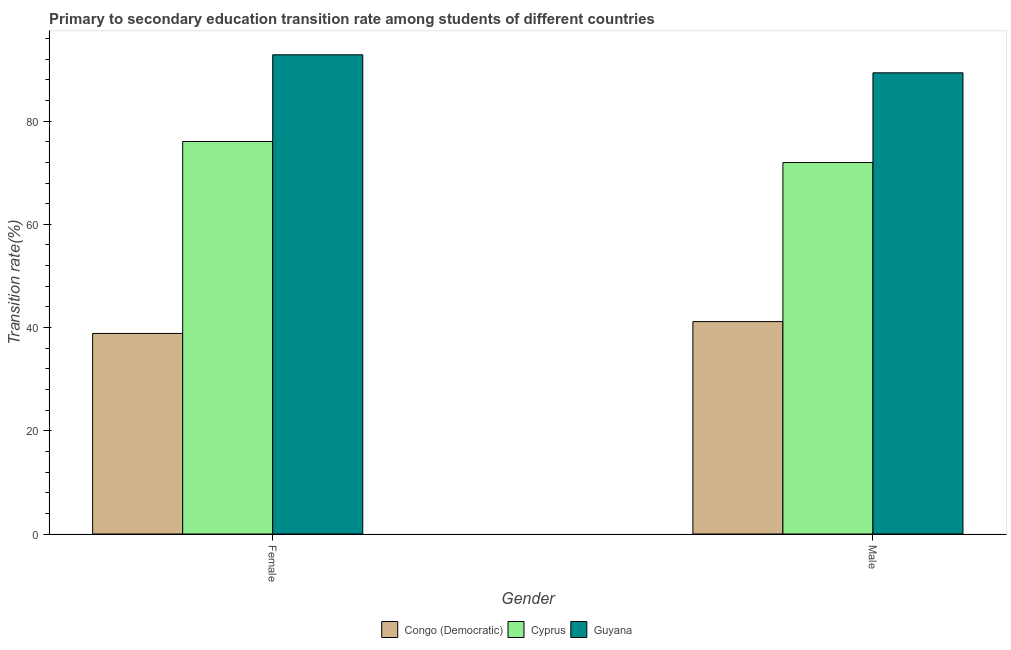How many groups of bars are there?
Your answer should be very brief. 2. Are the number of bars on each tick of the X-axis equal?
Your answer should be compact. Yes. How many bars are there on the 2nd tick from the right?
Offer a terse response. 3. What is the label of the 2nd group of bars from the left?
Your answer should be compact. Male. What is the transition rate among female students in Congo (Democratic)?
Give a very brief answer. 38.85. Across all countries, what is the maximum transition rate among female students?
Make the answer very short. 92.84. Across all countries, what is the minimum transition rate among female students?
Your answer should be compact. 38.85. In which country was the transition rate among female students maximum?
Offer a very short reply. Guyana. In which country was the transition rate among female students minimum?
Your answer should be compact. Congo (Democratic). What is the total transition rate among female students in the graph?
Your response must be concise. 207.74. What is the difference between the transition rate among female students in Guyana and that in Cyprus?
Your answer should be compact. 16.8. What is the difference between the transition rate among female students in Congo (Democratic) and the transition rate among male students in Guyana?
Make the answer very short. -50.49. What is the average transition rate among male students per country?
Keep it short and to the point. 67.49. What is the difference between the transition rate among female students and transition rate among male students in Congo (Democratic)?
Make the answer very short. -2.29. In how many countries, is the transition rate among male students greater than 52 %?
Your answer should be very brief. 2. What is the ratio of the transition rate among female students in Guyana to that in Cyprus?
Provide a succinct answer. 1.22. Is the transition rate among male students in Cyprus less than that in Guyana?
Your answer should be very brief. Yes. In how many countries, is the transition rate among male students greater than the average transition rate among male students taken over all countries?
Offer a terse response. 2. What does the 2nd bar from the left in Male represents?
Your answer should be compact. Cyprus. What does the 3rd bar from the right in Male represents?
Make the answer very short. Congo (Democratic). Are all the bars in the graph horizontal?
Offer a very short reply. No. How many countries are there in the graph?
Ensure brevity in your answer.  3. Are the values on the major ticks of Y-axis written in scientific E-notation?
Make the answer very short. No. Where does the legend appear in the graph?
Your answer should be very brief. Bottom center. What is the title of the graph?
Your answer should be very brief. Primary to secondary education transition rate among students of different countries. Does "Turkmenistan" appear as one of the legend labels in the graph?
Provide a short and direct response. No. What is the label or title of the Y-axis?
Make the answer very short. Transition rate(%). What is the Transition rate(%) in Congo (Democratic) in Female?
Your answer should be compact. 38.85. What is the Transition rate(%) in Cyprus in Female?
Provide a short and direct response. 76.04. What is the Transition rate(%) of Guyana in Female?
Make the answer very short. 92.84. What is the Transition rate(%) in Congo (Democratic) in Male?
Provide a succinct answer. 41.15. What is the Transition rate(%) of Cyprus in Male?
Your response must be concise. 71.96. What is the Transition rate(%) of Guyana in Male?
Your answer should be very brief. 89.35. Across all Gender, what is the maximum Transition rate(%) in Congo (Democratic)?
Your answer should be compact. 41.15. Across all Gender, what is the maximum Transition rate(%) of Cyprus?
Keep it short and to the point. 76.04. Across all Gender, what is the maximum Transition rate(%) in Guyana?
Offer a terse response. 92.84. Across all Gender, what is the minimum Transition rate(%) of Congo (Democratic)?
Make the answer very short. 38.85. Across all Gender, what is the minimum Transition rate(%) in Cyprus?
Your answer should be compact. 71.96. Across all Gender, what is the minimum Transition rate(%) in Guyana?
Provide a short and direct response. 89.35. What is the total Transition rate(%) of Congo (Democratic) in the graph?
Provide a short and direct response. 80. What is the total Transition rate(%) in Cyprus in the graph?
Your response must be concise. 148.01. What is the total Transition rate(%) in Guyana in the graph?
Offer a terse response. 182.19. What is the difference between the Transition rate(%) of Congo (Democratic) in Female and that in Male?
Your answer should be very brief. -2.29. What is the difference between the Transition rate(%) of Cyprus in Female and that in Male?
Offer a terse response. 4.08. What is the difference between the Transition rate(%) in Guyana in Female and that in Male?
Give a very brief answer. 3.49. What is the difference between the Transition rate(%) of Congo (Democratic) in Female and the Transition rate(%) of Cyprus in Male?
Offer a terse response. -33.11. What is the difference between the Transition rate(%) of Congo (Democratic) in Female and the Transition rate(%) of Guyana in Male?
Give a very brief answer. -50.49. What is the difference between the Transition rate(%) of Cyprus in Female and the Transition rate(%) of Guyana in Male?
Give a very brief answer. -13.3. What is the average Transition rate(%) in Congo (Democratic) per Gender?
Provide a short and direct response. 40. What is the average Transition rate(%) of Cyprus per Gender?
Keep it short and to the point. 74. What is the average Transition rate(%) in Guyana per Gender?
Ensure brevity in your answer.  91.09. What is the difference between the Transition rate(%) of Congo (Democratic) and Transition rate(%) of Cyprus in Female?
Offer a very short reply. -37.19. What is the difference between the Transition rate(%) in Congo (Democratic) and Transition rate(%) in Guyana in Female?
Your answer should be very brief. -53.99. What is the difference between the Transition rate(%) of Cyprus and Transition rate(%) of Guyana in Female?
Give a very brief answer. -16.8. What is the difference between the Transition rate(%) of Congo (Democratic) and Transition rate(%) of Cyprus in Male?
Provide a short and direct response. -30.82. What is the difference between the Transition rate(%) in Congo (Democratic) and Transition rate(%) in Guyana in Male?
Provide a succinct answer. -48.2. What is the difference between the Transition rate(%) of Cyprus and Transition rate(%) of Guyana in Male?
Provide a short and direct response. -17.38. What is the ratio of the Transition rate(%) in Congo (Democratic) in Female to that in Male?
Your answer should be very brief. 0.94. What is the ratio of the Transition rate(%) in Cyprus in Female to that in Male?
Make the answer very short. 1.06. What is the ratio of the Transition rate(%) of Guyana in Female to that in Male?
Ensure brevity in your answer.  1.04. What is the difference between the highest and the second highest Transition rate(%) of Congo (Democratic)?
Keep it short and to the point. 2.29. What is the difference between the highest and the second highest Transition rate(%) of Cyprus?
Offer a terse response. 4.08. What is the difference between the highest and the second highest Transition rate(%) of Guyana?
Your answer should be compact. 3.49. What is the difference between the highest and the lowest Transition rate(%) in Congo (Democratic)?
Your answer should be compact. 2.29. What is the difference between the highest and the lowest Transition rate(%) of Cyprus?
Keep it short and to the point. 4.08. What is the difference between the highest and the lowest Transition rate(%) of Guyana?
Keep it short and to the point. 3.49. 